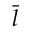Convert formula to latex. <formula><loc_0><loc_0><loc_500><loc_500>\bar { l }</formula> 